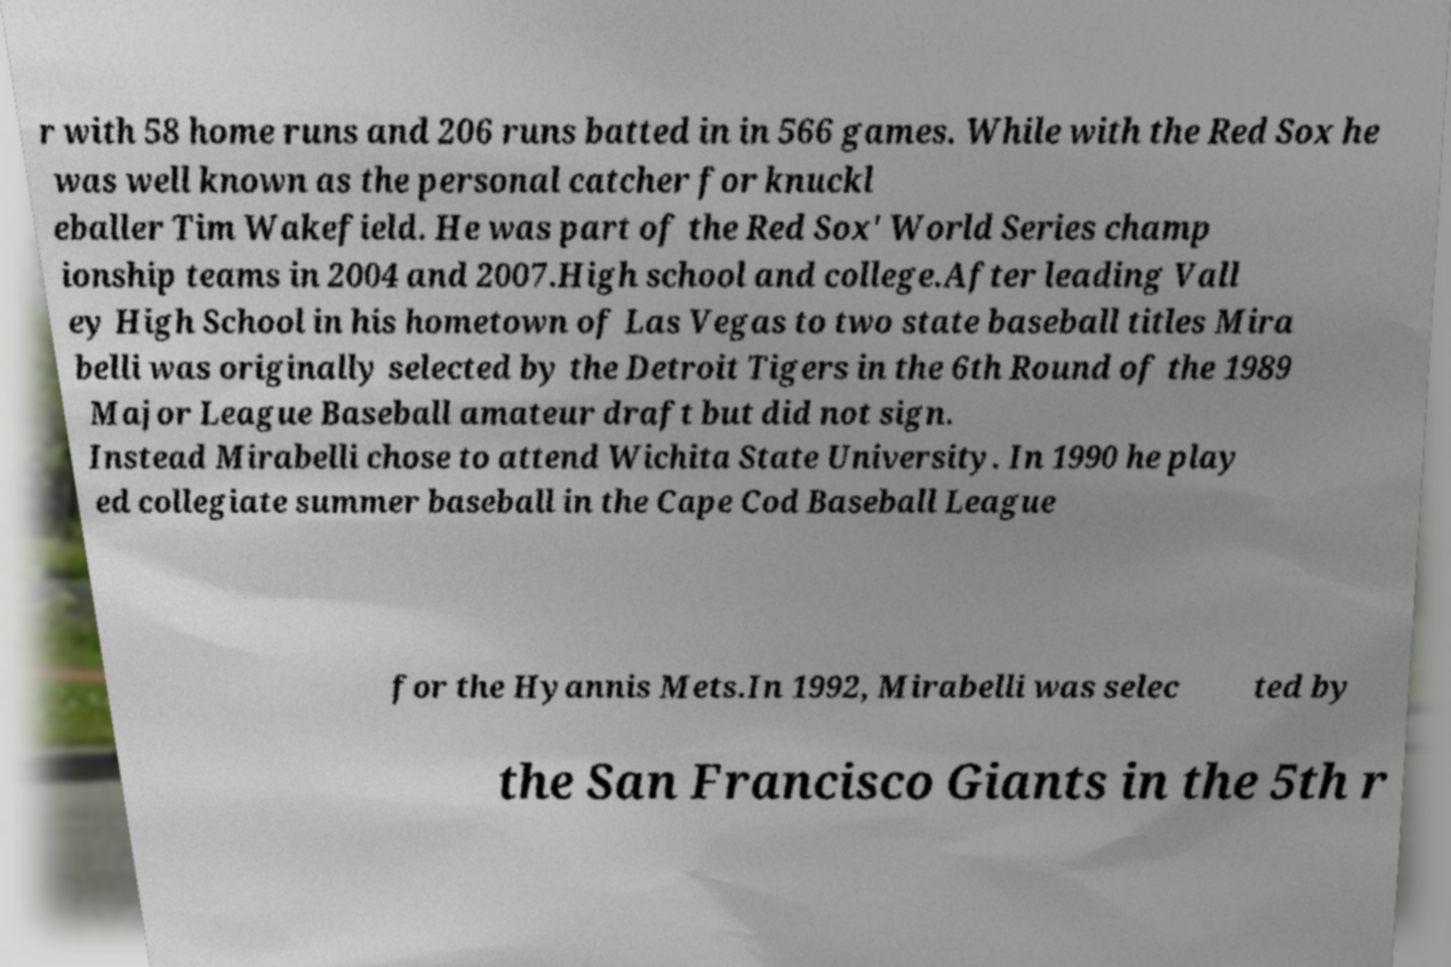I need the written content from this picture converted into text. Can you do that? r with 58 home runs and 206 runs batted in in 566 games. While with the Red Sox he was well known as the personal catcher for knuckl eballer Tim Wakefield. He was part of the Red Sox' World Series champ ionship teams in 2004 and 2007.High school and college.After leading Vall ey High School in his hometown of Las Vegas to two state baseball titles Mira belli was originally selected by the Detroit Tigers in the 6th Round of the 1989 Major League Baseball amateur draft but did not sign. Instead Mirabelli chose to attend Wichita State University. In 1990 he play ed collegiate summer baseball in the Cape Cod Baseball League for the Hyannis Mets.In 1992, Mirabelli was selec ted by the San Francisco Giants in the 5th r 